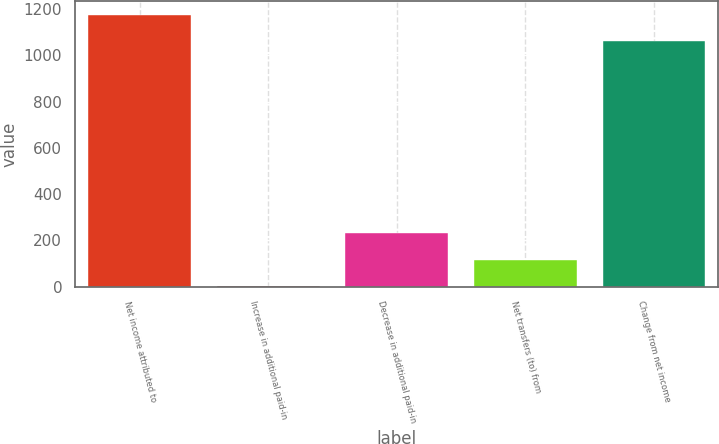<chart> <loc_0><loc_0><loc_500><loc_500><bar_chart><fcel>Net income attributed to<fcel>Increase in additional paid-in<fcel>Decrease in additional paid-in<fcel>Net transfers (to) from<fcel>Change from net income<nl><fcel>1175.56<fcel>2<fcel>231.32<fcel>116.66<fcel>1060.9<nl></chart> 